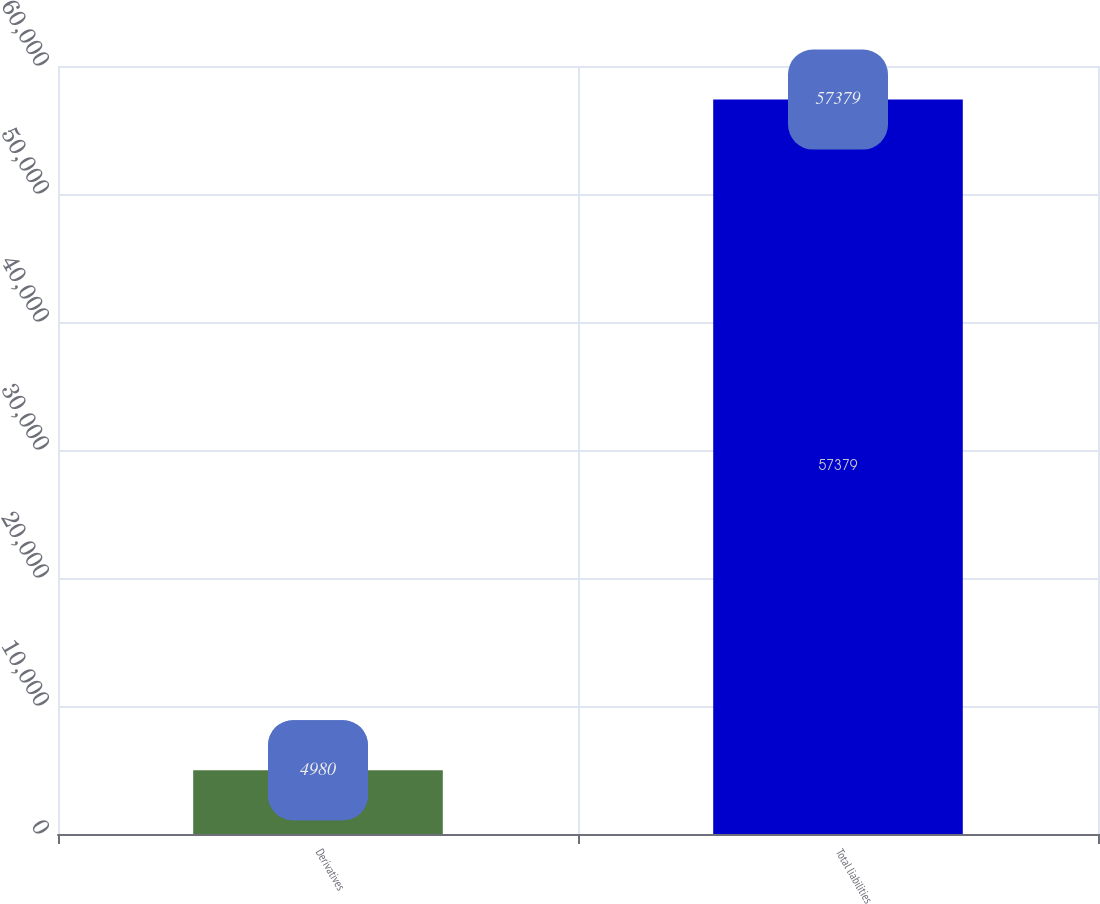Convert chart to OTSL. <chart><loc_0><loc_0><loc_500><loc_500><bar_chart><fcel>Derivatives<fcel>Total liabilities<nl><fcel>4980<fcel>57379<nl></chart> 